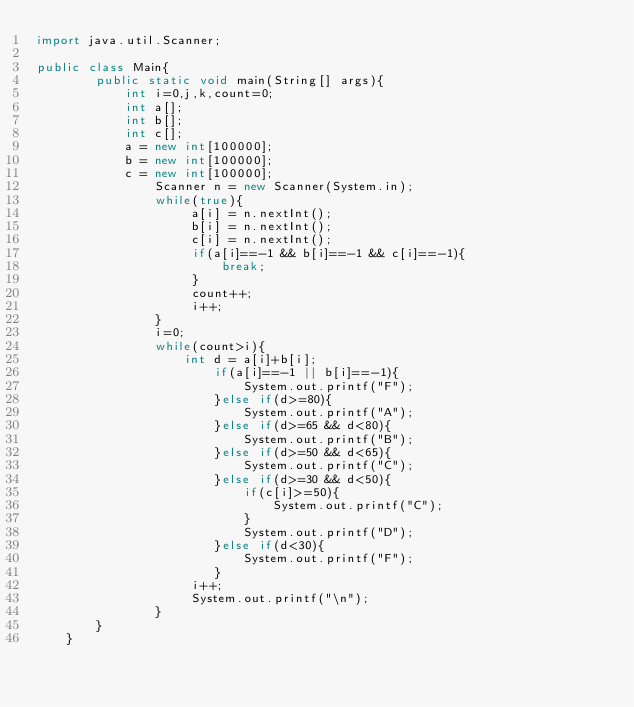<code> <loc_0><loc_0><loc_500><loc_500><_Java_>import java.util.Scanner;

public class Main{ 
        public static void main(String[] args){
            int i=0,j,k,count=0;
            int a[];
            int b[];
            int c[];
            a = new int[100000];
            b = new int[100000];
            c = new int[100000];
                Scanner n = new Scanner(System.in);
                while(true){
                     a[i] = n.nextInt();
                     b[i] = n.nextInt();
                     c[i] = n.nextInt();
                     if(a[i]==-1 && b[i]==-1 && c[i]==-1){
                         break;
                     }
                     count++;
                     i++;
                }
                i=0;
                while(count>i){
                    int d = a[i]+b[i];
                        if(a[i]==-1 || b[i]==-1){
                            System.out.printf("F");
                        }else if(d>=80){
                            System.out.printf("A");
                        }else if(d>=65 && d<80){
                            System.out.printf("B");
                        }else if(d>=50 && d<65){
                            System.out.printf("C");
                        }else if(d>=30 && d<50){
                            if(c[i]>=50){
                                System.out.printf("C");
                            }
                            System.out.printf("D");
                        }else if(d<30){
                            System.out.printf("F");
                        }
                     i++;
                     System.out.printf("\n");
                }
        }
    }
</code> 